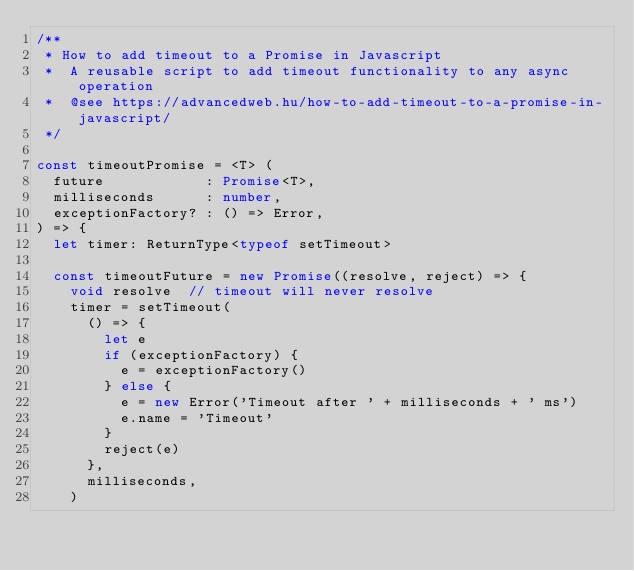Convert code to text. <code><loc_0><loc_0><loc_500><loc_500><_TypeScript_>/**
 * How to add timeout to a Promise in Javascript
 *  A reusable script to add timeout functionality to any async operation
 *  @see https://advancedweb.hu/how-to-add-timeout-to-a-promise-in-javascript/
 */

const timeoutPromise = <T> (
  future            : Promise<T>,
  milliseconds      : number,
  exceptionFactory? : () => Error,
) => {
  let timer: ReturnType<typeof setTimeout>

  const timeoutFuture = new Promise((resolve, reject) => {
    void resolve  // timeout will never resolve
    timer = setTimeout(
      () => {
        let e
        if (exceptionFactory) {
          e = exceptionFactory()
        } else {
          e = new Error('Timeout after ' + milliseconds + ' ms')
          e.name = 'Timeout'
        }
        reject(e)
      },
      milliseconds,
    )</code> 